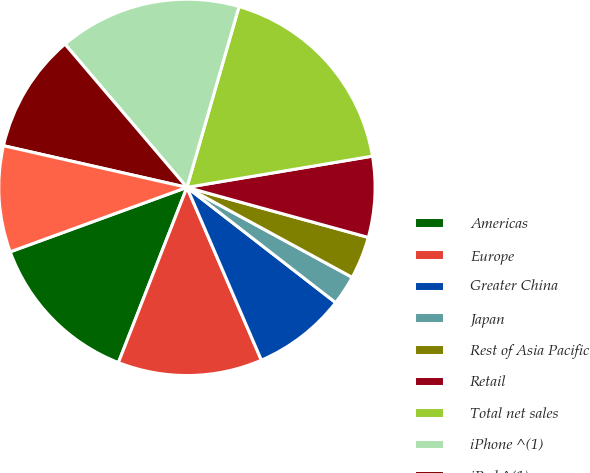Convert chart to OTSL. <chart><loc_0><loc_0><loc_500><loc_500><pie_chart><fcel>Americas<fcel>Europe<fcel>Greater China<fcel>Japan<fcel>Rest of Asia Pacific<fcel>Retail<fcel>Total net sales<fcel>iPhone ^(1)<fcel>iPad ^(1)<fcel>Mac ^(1)<nl><fcel>13.5%<fcel>12.41%<fcel>8.03%<fcel>2.56%<fcel>3.65%<fcel>6.94%<fcel>17.88%<fcel>15.69%<fcel>10.22%<fcel>9.12%<nl></chart> 